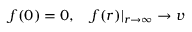Convert formula to latex. <formula><loc_0><loc_0><loc_500><loc_500>f ( 0 ) = 0 , f ( r ) | _ { r \rightarrow \infty } \rightarrow v</formula> 